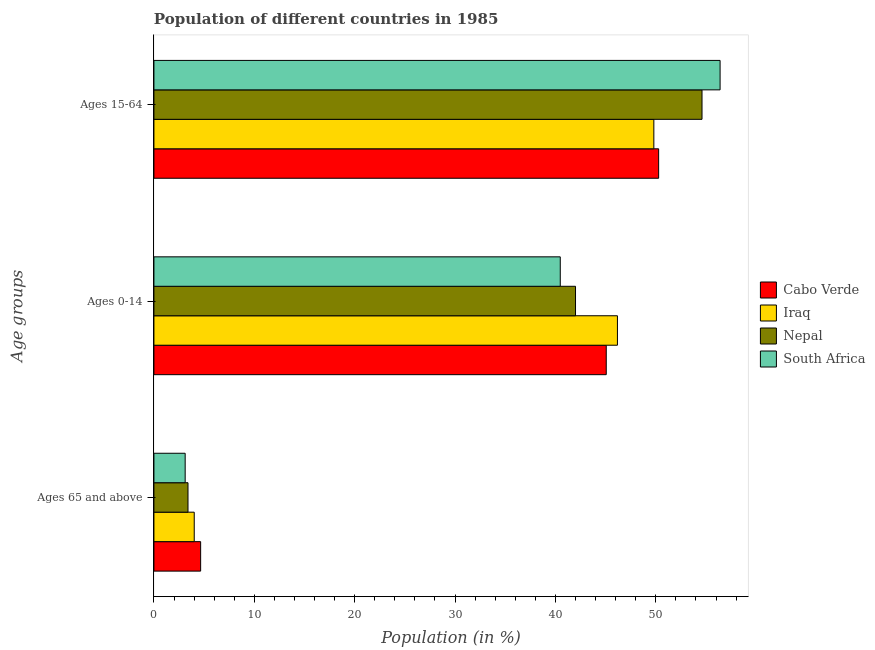How many groups of bars are there?
Your response must be concise. 3. Are the number of bars per tick equal to the number of legend labels?
Give a very brief answer. Yes. Are the number of bars on each tick of the Y-axis equal?
Your answer should be compact. Yes. What is the label of the 3rd group of bars from the top?
Give a very brief answer. Ages 65 and above. What is the percentage of population within the age-group of 65 and above in Cabo Verde?
Ensure brevity in your answer.  4.65. Across all countries, what is the maximum percentage of population within the age-group 0-14?
Offer a very short reply. 46.18. Across all countries, what is the minimum percentage of population within the age-group 0-14?
Ensure brevity in your answer.  40.48. In which country was the percentage of population within the age-group of 65 and above maximum?
Make the answer very short. Cabo Verde. In which country was the percentage of population within the age-group of 65 and above minimum?
Keep it short and to the point. South Africa. What is the total percentage of population within the age-group of 65 and above in the graph?
Provide a succinct answer. 15.18. What is the difference between the percentage of population within the age-group 15-64 in Nepal and that in Cabo Verde?
Offer a terse response. 4.32. What is the difference between the percentage of population within the age-group of 65 and above in South Africa and the percentage of population within the age-group 15-64 in Iraq?
Offer a very short reply. -46.69. What is the average percentage of population within the age-group of 65 and above per country?
Your answer should be very brief. 3.79. What is the difference between the percentage of population within the age-group 0-14 and percentage of population within the age-group 15-64 in Cabo Verde?
Your answer should be very brief. -5.22. In how many countries, is the percentage of population within the age-group 0-14 greater than 40 %?
Offer a terse response. 4. What is the ratio of the percentage of population within the age-group 15-64 in South Africa to that in Iraq?
Give a very brief answer. 1.13. Is the percentage of population within the age-group 0-14 in Iraq less than that in Nepal?
Provide a succinct answer. No. Is the difference between the percentage of population within the age-group of 65 and above in Nepal and Cabo Verde greater than the difference between the percentage of population within the age-group 0-14 in Nepal and Cabo Verde?
Keep it short and to the point. Yes. What is the difference between the highest and the second highest percentage of population within the age-group 0-14?
Provide a short and direct response. 1.12. What is the difference between the highest and the lowest percentage of population within the age-group of 65 and above?
Your answer should be compact. 1.54. What does the 4th bar from the top in Ages 15-64 represents?
Ensure brevity in your answer.  Cabo Verde. What does the 4th bar from the bottom in Ages 15-64 represents?
Give a very brief answer. South Africa. Is it the case that in every country, the sum of the percentage of population within the age-group of 65 and above and percentage of population within the age-group 0-14 is greater than the percentage of population within the age-group 15-64?
Your answer should be very brief. No. Does the graph contain any zero values?
Ensure brevity in your answer.  No. What is the title of the graph?
Your response must be concise. Population of different countries in 1985. What is the label or title of the Y-axis?
Give a very brief answer. Age groups. What is the Population (in %) in Cabo Verde in Ages 65 and above?
Offer a very short reply. 4.65. What is the Population (in %) of Iraq in Ages 65 and above?
Ensure brevity in your answer.  4.02. What is the Population (in %) of Nepal in Ages 65 and above?
Keep it short and to the point. 3.39. What is the Population (in %) in South Africa in Ages 65 and above?
Offer a terse response. 3.11. What is the Population (in %) in Cabo Verde in Ages 0-14?
Provide a short and direct response. 45.06. What is the Population (in %) in Iraq in Ages 0-14?
Your answer should be very brief. 46.18. What is the Population (in %) in Nepal in Ages 0-14?
Provide a succinct answer. 42. What is the Population (in %) in South Africa in Ages 0-14?
Your answer should be compact. 40.48. What is the Population (in %) of Cabo Verde in Ages 15-64?
Provide a succinct answer. 50.28. What is the Population (in %) of Iraq in Ages 15-64?
Your response must be concise. 49.81. What is the Population (in %) of Nepal in Ages 15-64?
Provide a short and direct response. 54.6. What is the Population (in %) in South Africa in Ages 15-64?
Your answer should be very brief. 56.41. Across all Age groups, what is the maximum Population (in %) in Cabo Verde?
Give a very brief answer. 50.28. Across all Age groups, what is the maximum Population (in %) in Iraq?
Your answer should be compact. 49.81. Across all Age groups, what is the maximum Population (in %) of Nepal?
Provide a succinct answer. 54.6. Across all Age groups, what is the maximum Population (in %) in South Africa?
Provide a succinct answer. 56.41. Across all Age groups, what is the minimum Population (in %) of Cabo Verde?
Provide a succinct answer. 4.65. Across all Age groups, what is the minimum Population (in %) of Iraq?
Your response must be concise. 4.02. Across all Age groups, what is the minimum Population (in %) of Nepal?
Your answer should be very brief. 3.39. Across all Age groups, what is the minimum Population (in %) in South Africa?
Make the answer very short. 3.11. What is the total Population (in %) of Cabo Verde in the graph?
Offer a terse response. 100. What is the total Population (in %) in Nepal in the graph?
Provide a succinct answer. 100. What is the total Population (in %) in South Africa in the graph?
Provide a succinct answer. 100. What is the difference between the Population (in %) in Cabo Verde in Ages 65 and above and that in Ages 0-14?
Your answer should be compact. -40.41. What is the difference between the Population (in %) in Iraq in Ages 65 and above and that in Ages 0-14?
Your answer should be very brief. -42.16. What is the difference between the Population (in %) in Nepal in Ages 65 and above and that in Ages 0-14?
Your answer should be very brief. -38.61. What is the difference between the Population (in %) in South Africa in Ages 65 and above and that in Ages 0-14?
Provide a succinct answer. -37.37. What is the difference between the Population (in %) in Cabo Verde in Ages 65 and above and that in Ages 15-64?
Your response must be concise. -45.63. What is the difference between the Population (in %) in Iraq in Ages 65 and above and that in Ages 15-64?
Offer a terse response. -45.79. What is the difference between the Population (in %) of Nepal in Ages 65 and above and that in Ages 15-64?
Offer a terse response. -51.21. What is the difference between the Population (in %) of South Africa in Ages 65 and above and that in Ages 15-64?
Give a very brief answer. -53.29. What is the difference between the Population (in %) of Cabo Verde in Ages 0-14 and that in Ages 15-64?
Offer a very short reply. -5.22. What is the difference between the Population (in %) of Iraq in Ages 0-14 and that in Ages 15-64?
Your response must be concise. -3.63. What is the difference between the Population (in %) of Nepal in Ages 0-14 and that in Ages 15-64?
Make the answer very short. -12.6. What is the difference between the Population (in %) in South Africa in Ages 0-14 and that in Ages 15-64?
Your response must be concise. -15.92. What is the difference between the Population (in %) of Cabo Verde in Ages 65 and above and the Population (in %) of Iraq in Ages 0-14?
Your answer should be compact. -41.52. What is the difference between the Population (in %) of Cabo Verde in Ages 65 and above and the Population (in %) of Nepal in Ages 0-14?
Provide a succinct answer. -37.35. What is the difference between the Population (in %) in Cabo Verde in Ages 65 and above and the Population (in %) in South Africa in Ages 0-14?
Give a very brief answer. -35.83. What is the difference between the Population (in %) of Iraq in Ages 65 and above and the Population (in %) of Nepal in Ages 0-14?
Provide a short and direct response. -37.99. What is the difference between the Population (in %) in Iraq in Ages 65 and above and the Population (in %) in South Africa in Ages 0-14?
Your response must be concise. -36.47. What is the difference between the Population (in %) in Nepal in Ages 65 and above and the Population (in %) in South Africa in Ages 0-14?
Give a very brief answer. -37.09. What is the difference between the Population (in %) of Cabo Verde in Ages 65 and above and the Population (in %) of Iraq in Ages 15-64?
Your response must be concise. -45.15. What is the difference between the Population (in %) of Cabo Verde in Ages 65 and above and the Population (in %) of Nepal in Ages 15-64?
Your response must be concise. -49.95. What is the difference between the Population (in %) of Cabo Verde in Ages 65 and above and the Population (in %) of South Africa in Ages 15-64?
Your response must be concise. -51.75. What is the difference between the Population (in %) in Iraq in Ages 65 and above and the Population (in %) in Nepal in Ages 15-64?
Give a very brief answer. -50.59. What is the difference between the Population (in %) of Iraq in Ages 65 and above and the Population (in %) of South Africa in Ages 15-64?
Provide a short and direct response. -52.39. What is the difference between the Population (in %) in Nepal in Ages 65 and above and the Population (in %) in South Africa in Ages 15-64?
Provide a succinct answer. -53.01. What is the difference between the Population (in %) in Cabo Verde in Ages 0-14 and the Population (in %) in Iraq in Ages 15-64?
Ensure brevity in your answer.  -4.74. What is the difference between the Population (in %) in Cabo Verde in Ages 0-14 and the Population (in %) in Nepal in Ages 15-64?
Give a very brief answer. -9.54. What is the difference between the Population (in %) of Cabo Verde in Ages 0-14 and the Population (in %) of South Africa in Ages 15-64?
Make the answer very short. -11.34. What is the difference between the Population (in %) in Iraq in Ages 0-14 and the Population (in %) in Nepal in Ages 15-64?
Give a very brief answer. -8.43. What is the difference between the Population (in %) of Iraq in Ages 0-14 and the Population (in %) of South Africa in Ages 15-64?
Make the answer very short. -10.23. What is the difference between the Population (in %) in Nepal in Ages 0-14 and the Population (in %) in South Africa in Ages 15-64?
Make the answer very short. -14.4. What is the average Population (in %) of Cabo Verde per Age groups?
Provide a succinct answer. 33.33. What is the average Population (in %) in Iraq per Age groups?
Give a very brief answer. 33.33. What is the average Population (in %) in Nepal per Age groups?
Your response must be concise. 33.33. What is the average Population (in %) in South Africa per Age groups?
Ensure brevity in your answer.  33.33. What is the difference between the Population (in %) in Cabo Verde and Population (in %) in Iraq in Ages 65 and above?
Your answer should be compact. 0.64. What is the difference between the Population (in %) in Cabo Verde and Population (in %) in Nepal in Ages 65 and above?
Provide a succinct answer. 1.26. What is the difference between the Population (in %) in Cabo Verde and Population (in %) in South Africa in Ages 65 and above?
Ensure brevity in your answer.  1.54. What is the difference between the Population (in %) of Iraq and Population (in %) of Nepal in Ages 65 and above?
Give a very brief answer. 0.62. What is the difference between the Population (in %) in Iraq and Population (in %) in South Africa in Ages 65 and above?
Offer a very short reply. 0.9. What is the difference between the Population (in %) of Nepal and Population (in %) of South Africa in Ages 65 and above?
Ensure brevity in your answer.  0.28. What is the difference between the Population (in %) in Cabo Verde and Population (in %) in Iraq in Ages 0-14?
Offer a terse response. -1.12. What is the difference between the Population (in %) of Cabo Verde and Population (in %) of Nepal in Ages 0-14?
Your response must be concise. 3.06. What is the difference between the Population (in %) of Cabo Verde and Population (in %) of South Africa in Ages 0-14?
Your answer should be compact. 4.58. What is the difference between the Population (in %) of Iraq and Population (in %) of Nepal in Ages 0-14?
Make the answer very short. 4.18. What is the difference between the Population (in %) of Iraq and Population (in %) of South Africa in Ages 0-14?
Ensure brevity in your answer.  5.7. What is the difference between the Population (in %) of Nepal and Population (in %) of South Africa in Ages 0-14?
Your answer should be very brief. 1.52. What is the difference between the Population (in %) in Cabo Verde and Population (in %) in Iraq in Ages 15-64?
Your answer should be very brief. 0.48. What is the difference between the Population (in %) in Cabo Verde and Population (in %) in Nepal in Ages 15-64?
Your response must be concise. -4.32. What is the difference between the Population (in %) in Cabo Verde and Population (in %) in South Africa in Ages 15-64?
Make the answer very short. -6.12. What is the difference between the Population (in %) of Iraq and Population (in %) of Nepal in Ages 15-64?
Give a very brief answer. -4.8. What is the difference between the Population (in %) in Iraq and Population (in %) in South Africa in Ages 15-64?
Offer a very short reply. -6.6. What is the difference between the Population (in %) of Nepal and Population (in %) of South Africa in Ages 15-64?
Make the answer very short. -1.8. What is the ratio of the Population (in %) in Cabo Verde in Ages 65 and above to that in Ages 0-14?
Provide a short and direct response. 0.1. What is the ratio of the Population (in %) of Iraq in Ages 65 and above to that in Ages 0-14?
Your answer should be very brief. 0.09. What is the ratio of the Population (in %) in Nepal in Ages 65 and above to that in Ages 0-14?
Make the answer very short. 0.08. What is the ratio of the Population (in %) in South Africa in Ages 65 and above to that in Ages 0-14?
Your answer should be compact. 0.08. What is the ratio of the Population (in %) in Cabo Verde in Ages 65 and above to that in Ages 15-64?
Your answer should be compact. 0.09. What is the ratio of the Population (in %) of Iraq in Ages 65 and above to that in Ages 15-64?
Give a very brief answer. 0.08. What is the ratio of the Population (in %) of Nepal in Ages 65 and above to that in Ages 15-64?
Your answer should be compact. 0.06. What is the ratio of the Population (in %) in South Africa in Ages 65 and above to that in Ages 15-64?
Your answer should be compact. 0.06. What is the ratio of the Population (in %) of Cabo Verde in Ages 0-14 to that in Ages 15-64?
Your answer should be compact. 0.9. What is the ratio of the Population (in %) of Iraq in Ages 0-14 to that in Ages 15-64?
Make the answer very short. 0.93. What is the ratio of the Population (in %) in Nepal in Ages 0-14 to that in Ages 15-64?
Provide a short and direct response. 0.77. What is the ratio of the Population (in %) in South Africa in Ages 0-14 to that in Ages 15-64?
Keep it short and to the point. 0.72. What is the difference between the highest and the second highest Population (in %) of Cabo Verde?
Offer a terse response. 5.22. What is the difference between the highest and the second highest Population (in %) in Iraq?
Give a very brief answer. 3.63. What is the difference between the highest and the second highest Population (in %) in Nepal?
Ensure brevity in your answer.  12.6. What is the difference between the highest and the second highest Population (in %) of South Africa?
Give a very brief answer. 15.92. What is the difference between the highest and the lowest Population (in %) in Cabo Verde?
Keep it short and to the point. 45.63. What is the difference between the highest and the lowest Population (in %) in Iraq?
Offer a very short reply. 45.79. What is the difference between the highest and the lowest Population (in %) in Nepal?
Keep it short and to the point. 51.21. What is the difference between the highest and the lowest Population (in %) in South Africa?
Provide a short and direct response. 53.29. 